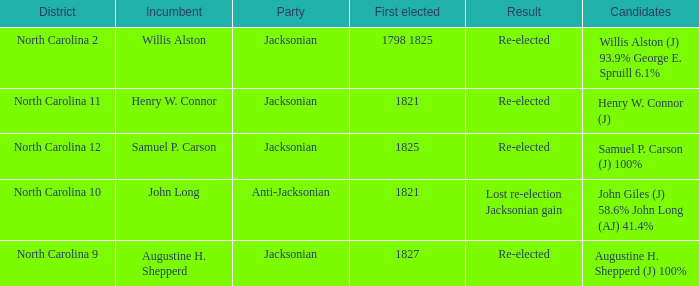Specify the area for anti-jacksonian North Carolina 10. 